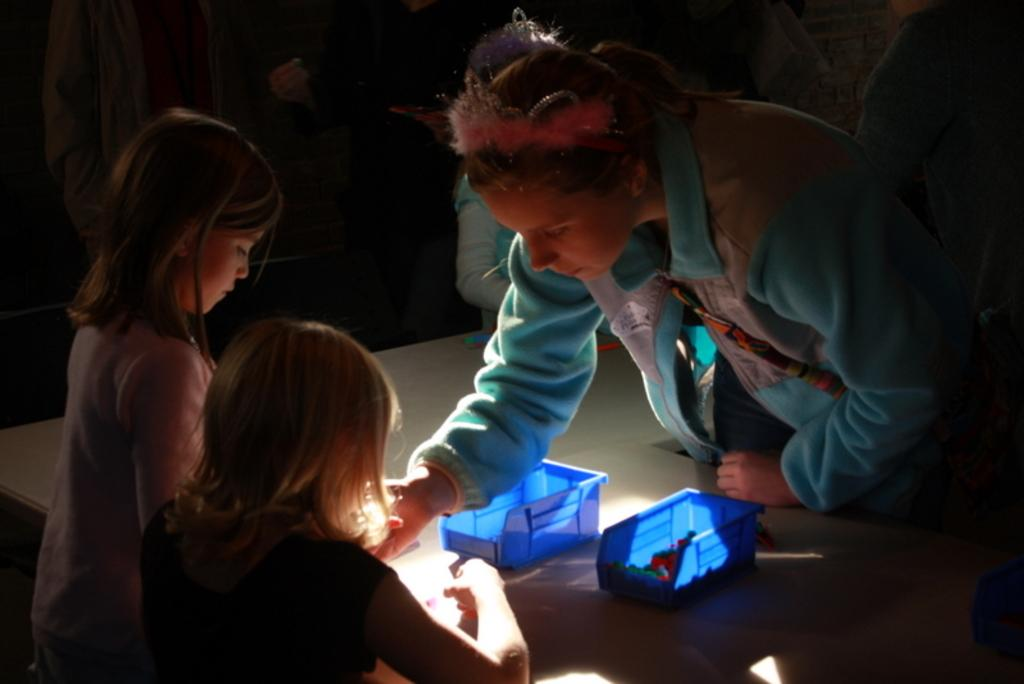Who is present in the image? There is a woman and two girls in the image. What are the girls doing in the image? The girls are playing with a toy in the image. Where are the toys located in the image? There is a basket of toys on a table in the image. What type of metal can be seen at the seashore in the image? There is no metal or seashore present in the image; it features a woman and two girls playing with a toy. 